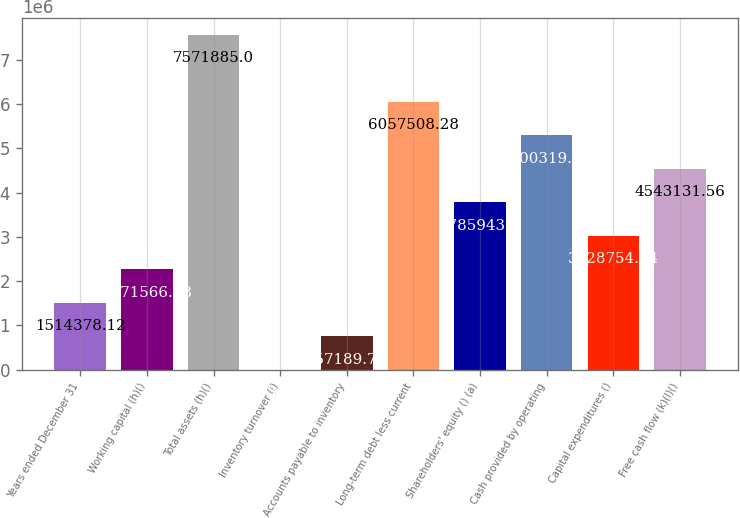<chart> <loc_0><loc_0><loc_500><loc_500><bar_chart><fcel>Years ended December 31<fcel>Working capital (h)()<fcel>Total assets (h)()<fcel>Inventory turnover (i)<fcel>Accounts payable to inventory<fcel>Long-term debt less current<fcel>Shareholders' equity () (a)<fcel>Cash provided by operating<fcel>Capital expenditures ()<fcel>Free cash flow (k)(l)()<nl><fcel>1.51438e+06<fcel>2.27157e+06<fcel>7.57188e+06<fcel>1.4<fcel>757190<fcel>6.05751e+06<fcel>3.78594e+06<fcel>5.30032e+06<fcel>3.02875e+06<fcel>4.54313e+06<nl></chart> 